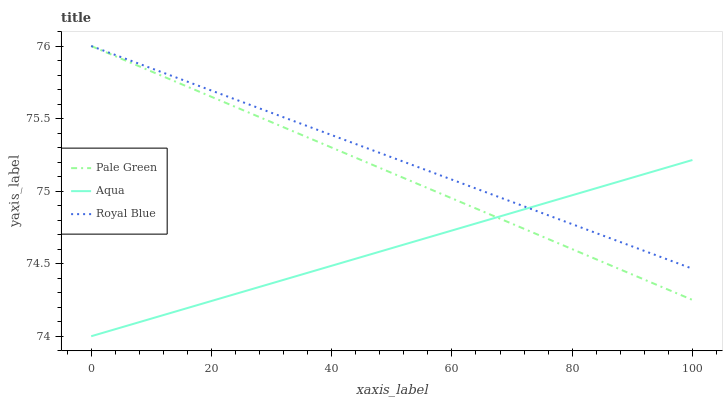Does Pale Green have the minimum area under the curve?
Answer yes or no. No. Does Pale Green have the maximum area under the curve?
Answer yes or no. No. Is Aqua the smoothest?
Answer yes or no. No. Is Aqua the roughest?
Answer yes or no. No. Does Pale Green have the lowest value?
Answer yes or no. No. Does Aqua have the highest value?
Answer yes or no. No. 